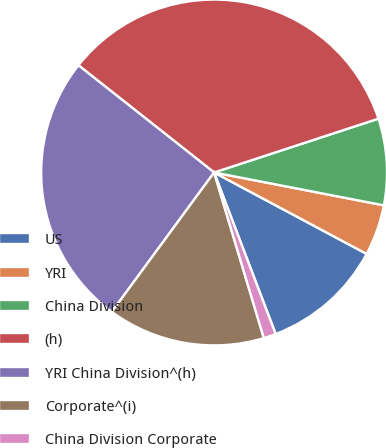Convert chart. <chart><loc_0><loc_0><loc_500><loc_500><pie_chart><fcel>US<fcel>YRI<fcel>China Division<fcel>(h)<fcel>YRI China Division^(h)<fcel>Corporate^(i)<fcel>China Division Corporate<nl><fcel>11.4%<fcel>4.76%<fcel>8.08%<fcel>34.32%<fcel>25.56%<fcel>14.72%<fcel>1.15%<nl></chart> 